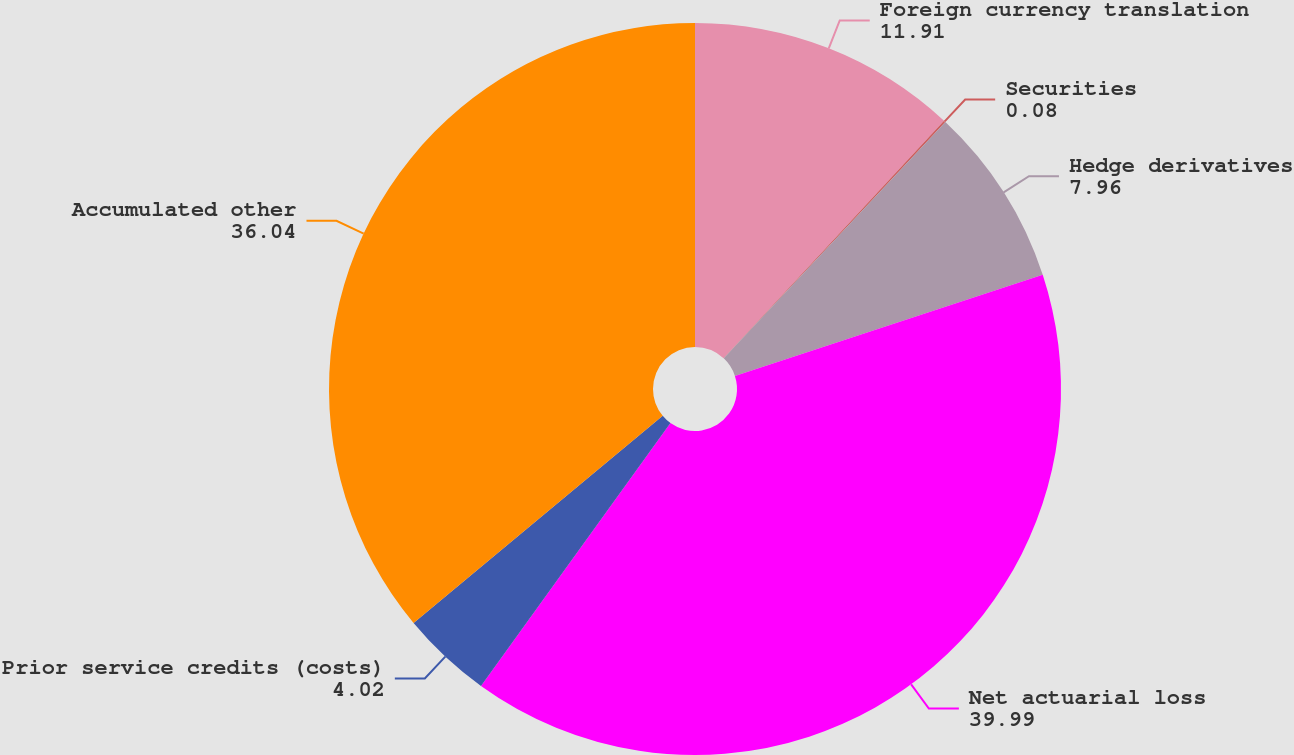Convert chart to OTSL. <chart><loc_0><loc_0><loc_500><loc_500><pie_chart><fcel>Foreign currency translation<fcel>Securities<fcel>Hedge derivatives<fcel>Net actuarial loss<fcel>Prior service credits (costs)<fcel>Accumulated other<nl><fcel>11.91%<fcel>0.08%<fcel>7.96%<fcel>39.99%<fcel>4.02%<fcel>36.04%<nl></chart> 